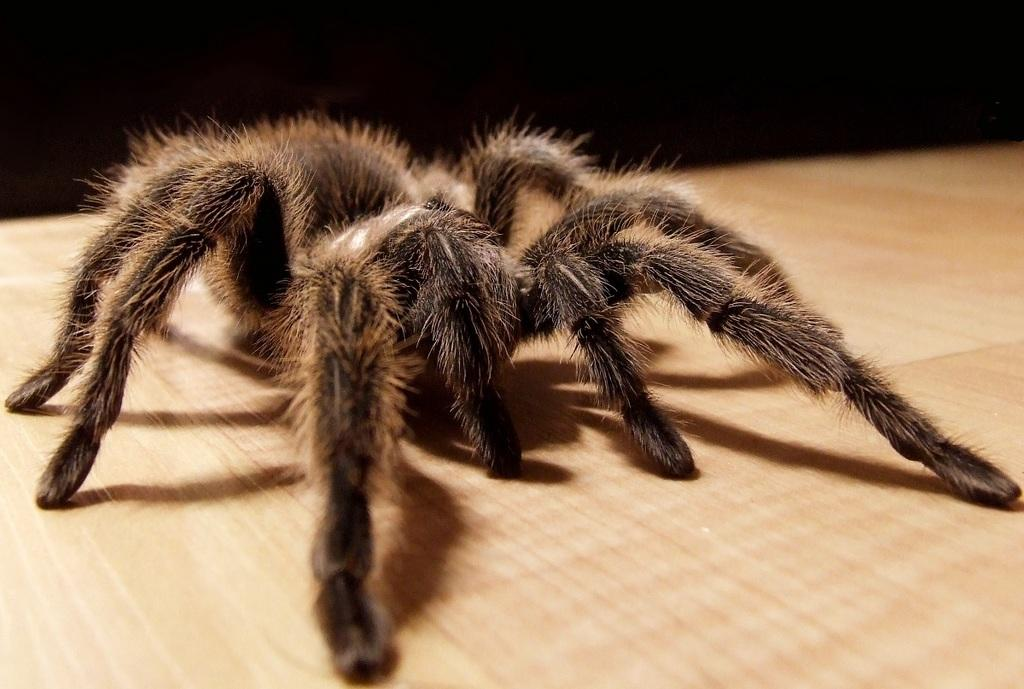What type of creature is present in the image? There is a spider in the image. Can you describe the color of the spider? The spider has brown and black color. What type of string is the spider using to create a pattern on its skin in the image? There is no string or pattern on the spider's skin in the image; it is simply a brown and black spider. What type of toad can be seen interacting with the spider in the image? There is no toad present in the image; only the spider is visible. 